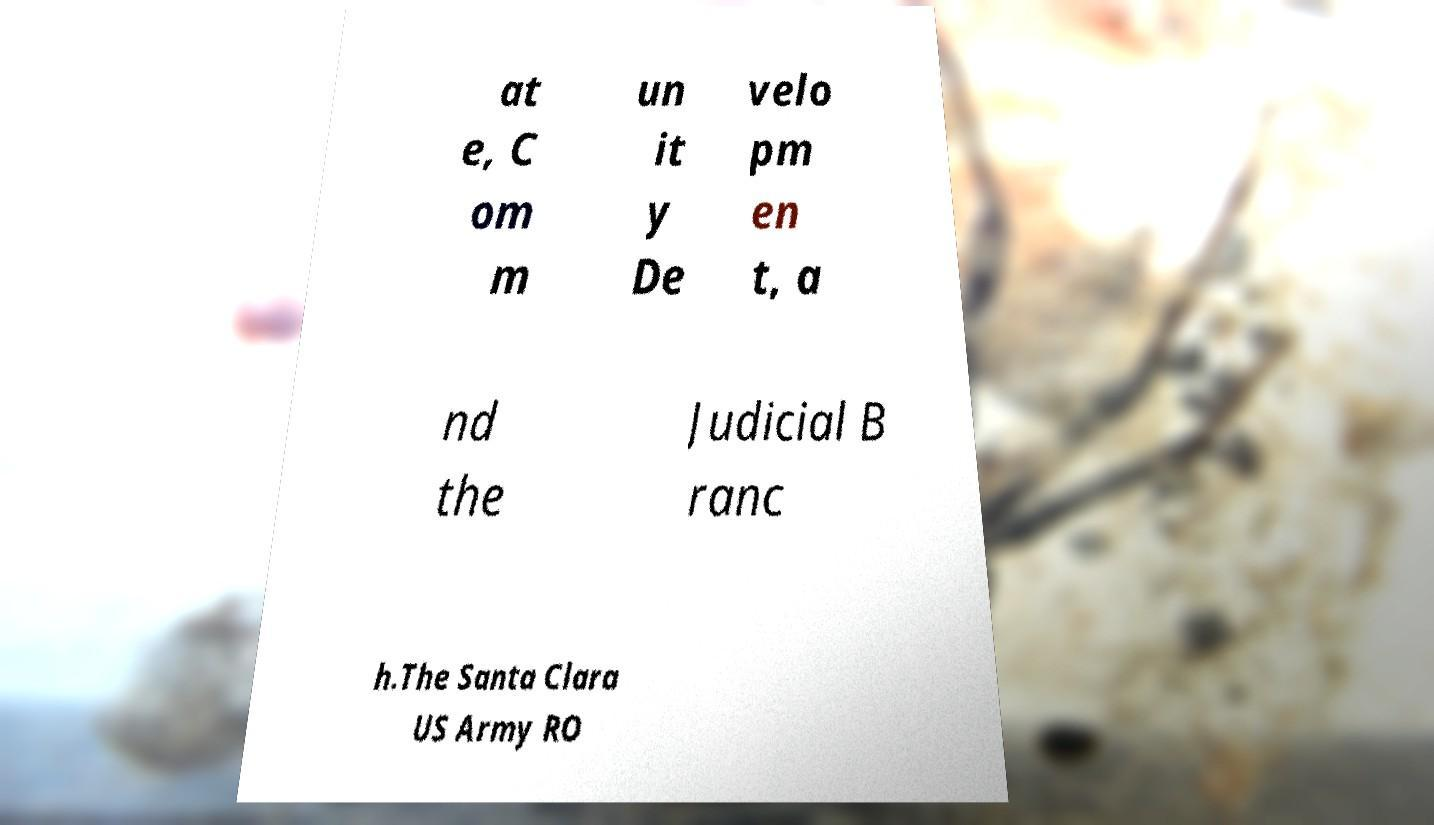Please read and relay the text visible in this image. What does it say? at e, C om m un it y De velo pm en t, a nd the Judicial B ranc h.The Santa Clara US Army RO 